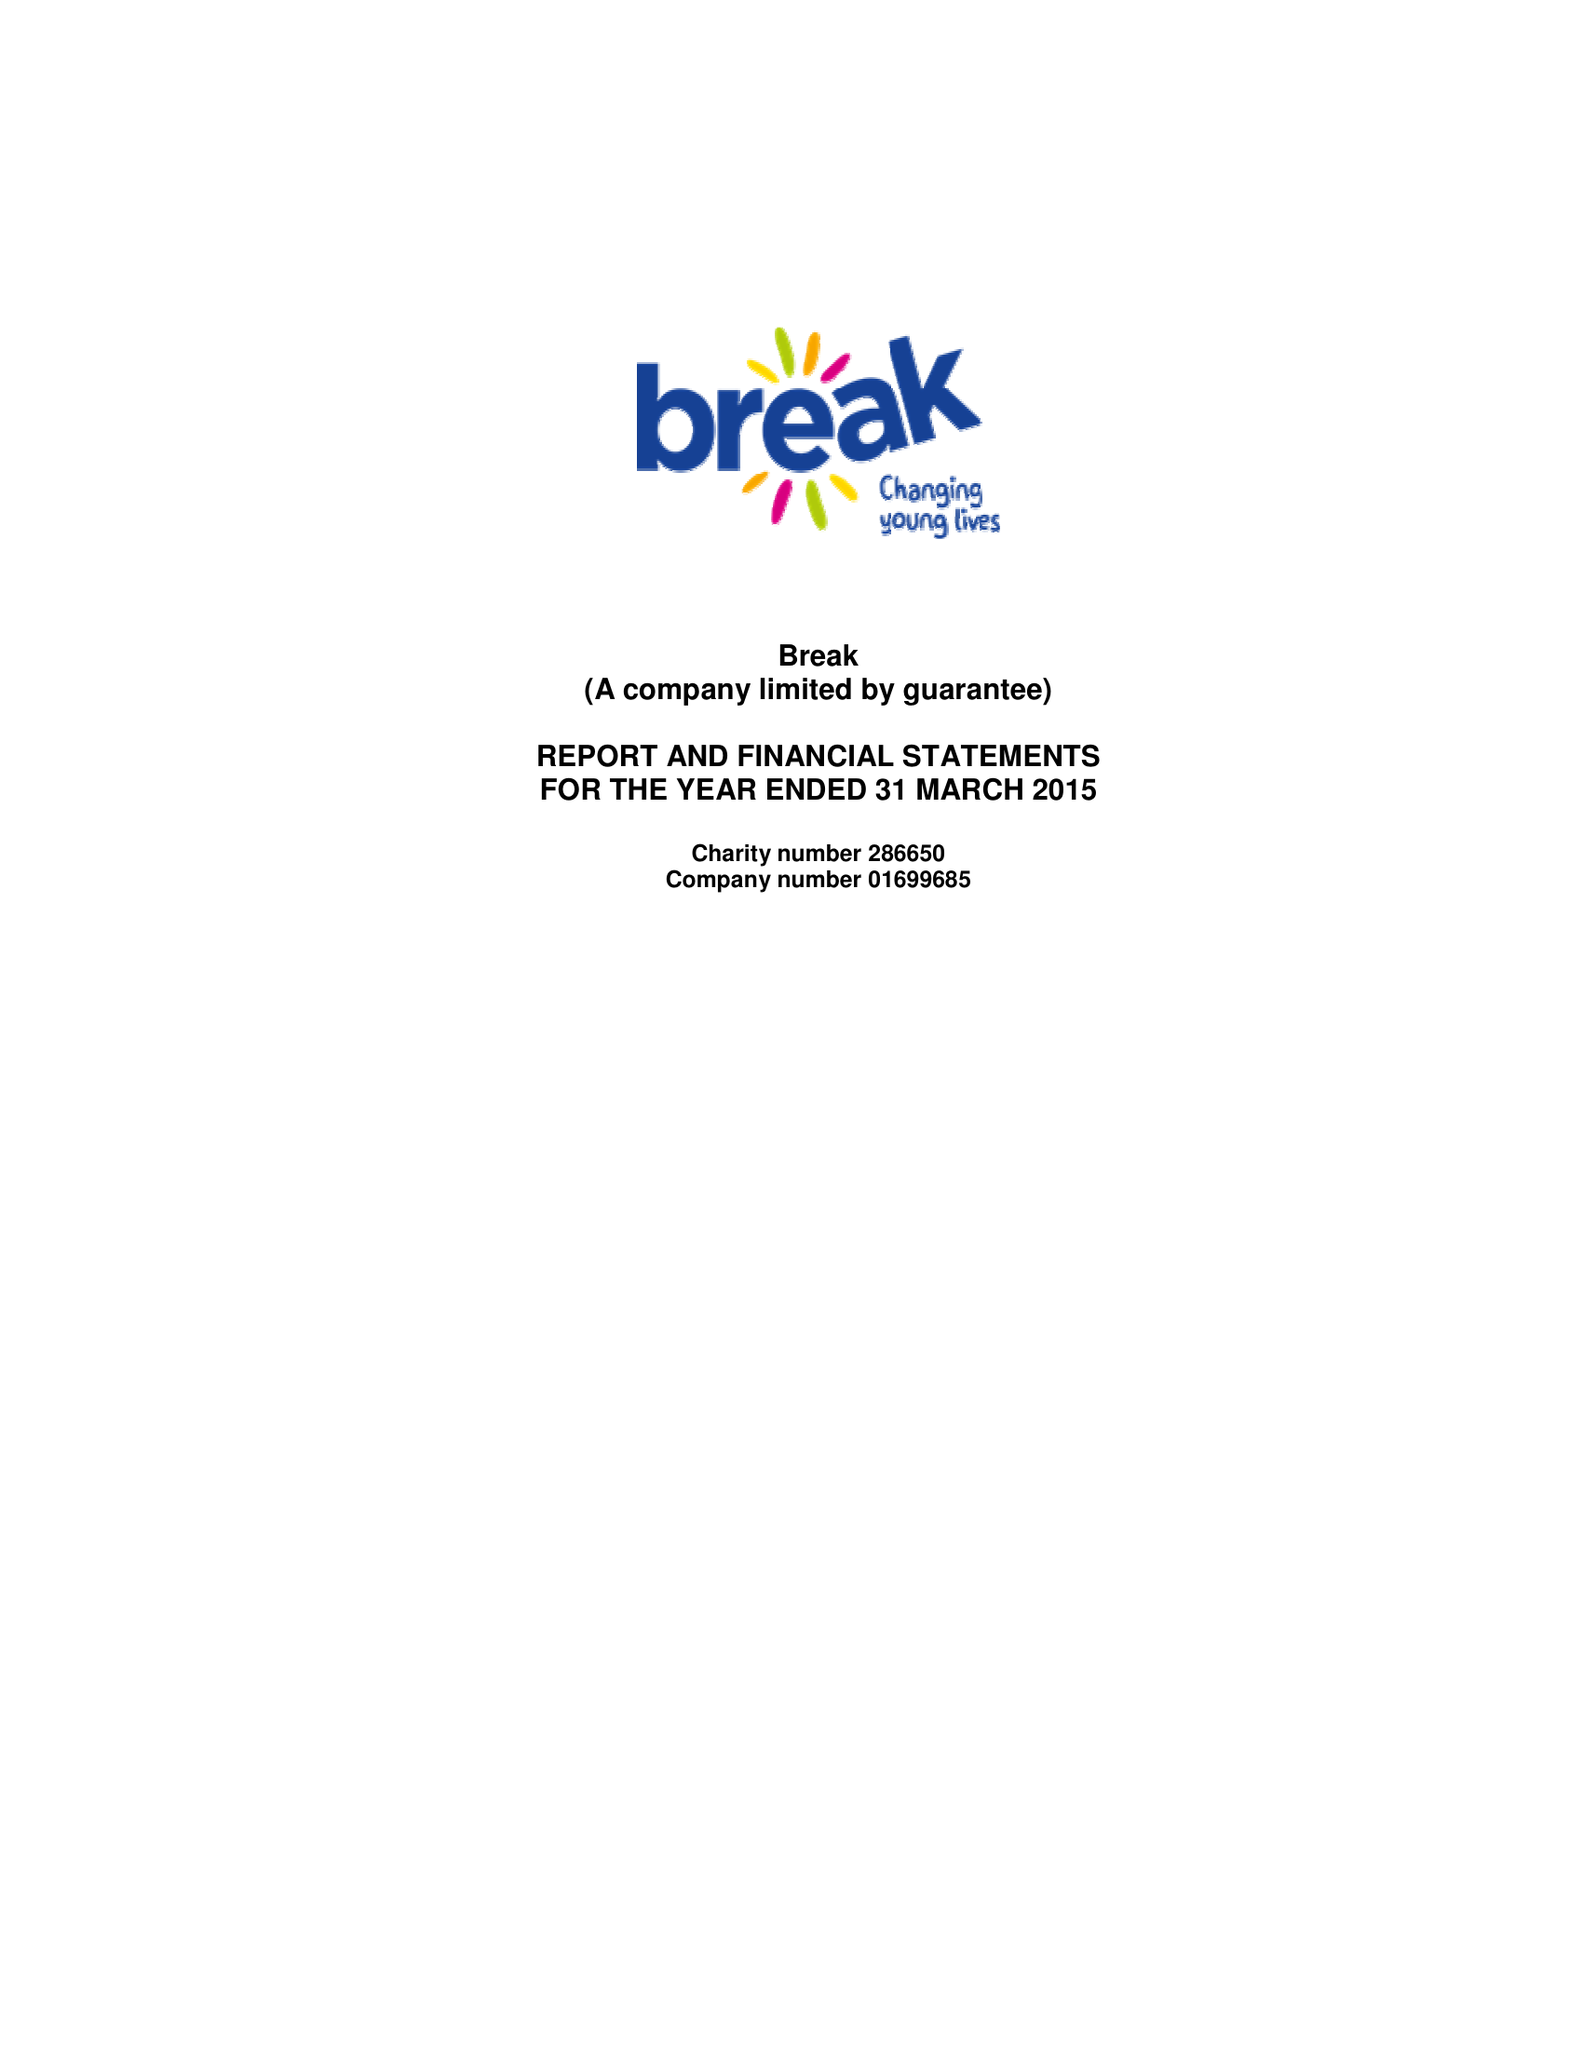What is the value for the charity_name?
Answer the question using a single word or phrase. Break 